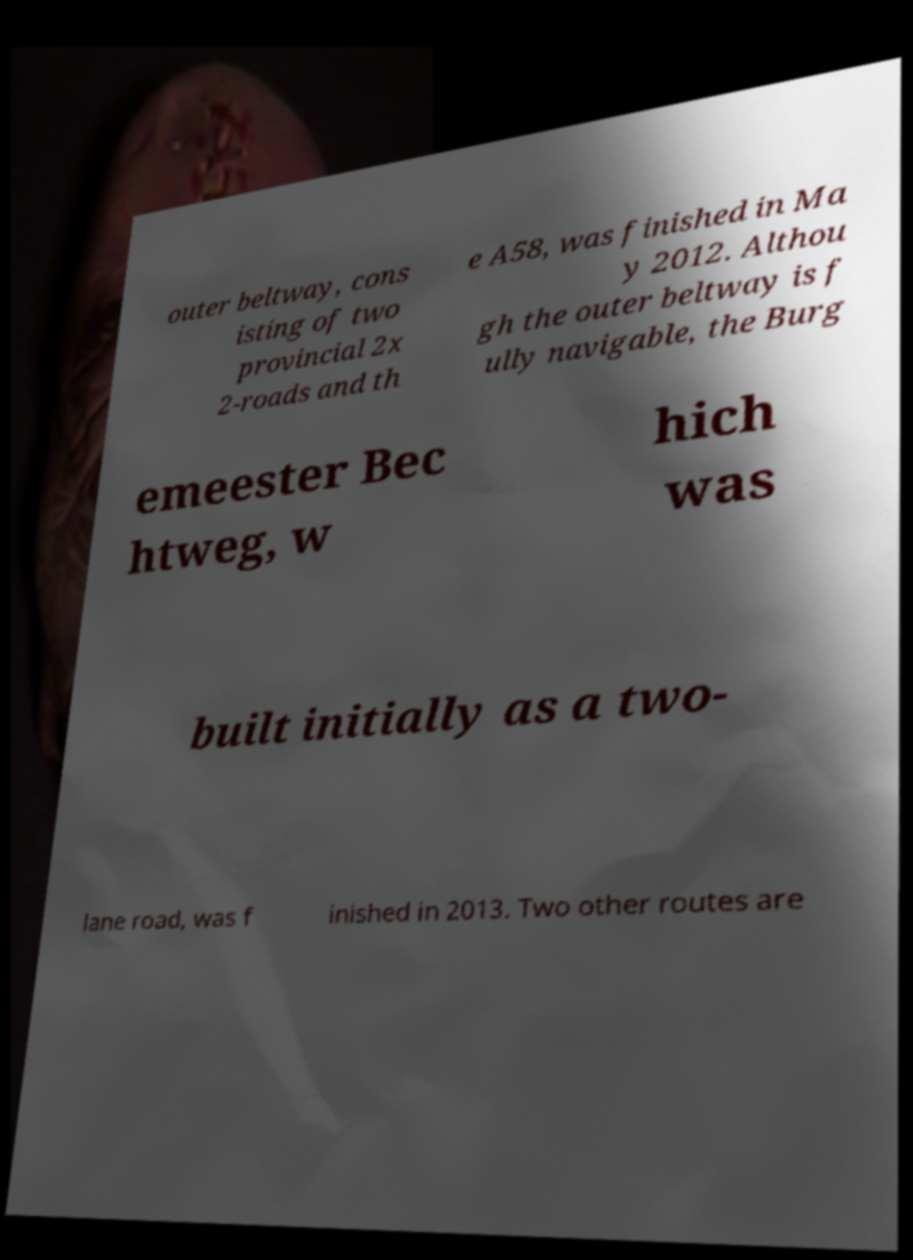Could you assist in decoding the text presented in this image and type it out clearly? outer beltway, cons isting of two provincial 2x 2-roads and th e A58, was finished in Ma y 2012. Althou gh the outer beltway is f ully navigable, the Burg emeester Bec htweg, w hich was built initially as a two- lane road, was f inished in 2013. Two other routes are 